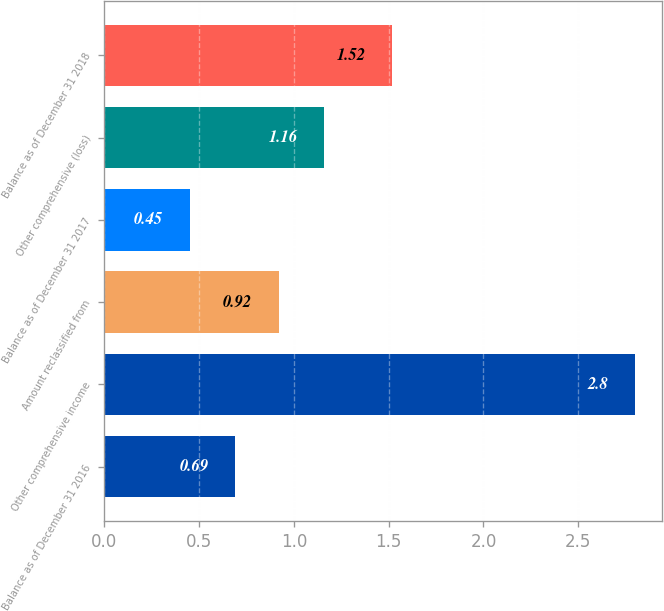<chart> <loc_0><loc_0><loc_500><loc_500><bar_chart><fcel>Balance as of December 31 2016<fcel>Other comprehensive income<fcel>Amount reclassified from<fcel>Balance as of December 31 2017<fcel>Other comprehensive (loss)<fcel>Balance as of December 31 2018<nl><fcel>0.69<fcel>2.8<fcel>0.92<fcel>0.45<fcel>1.16<fcel>1.52<nl></chart> 